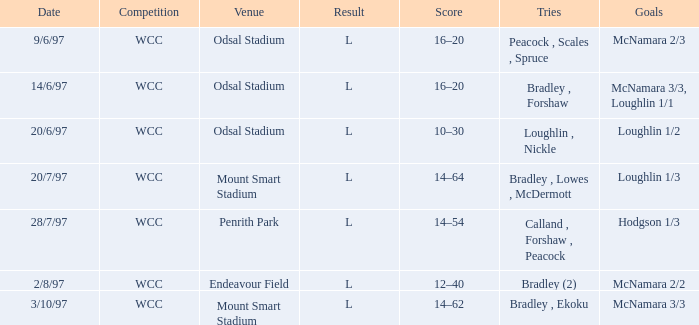What was the score on 20/6/97? 10–30. 